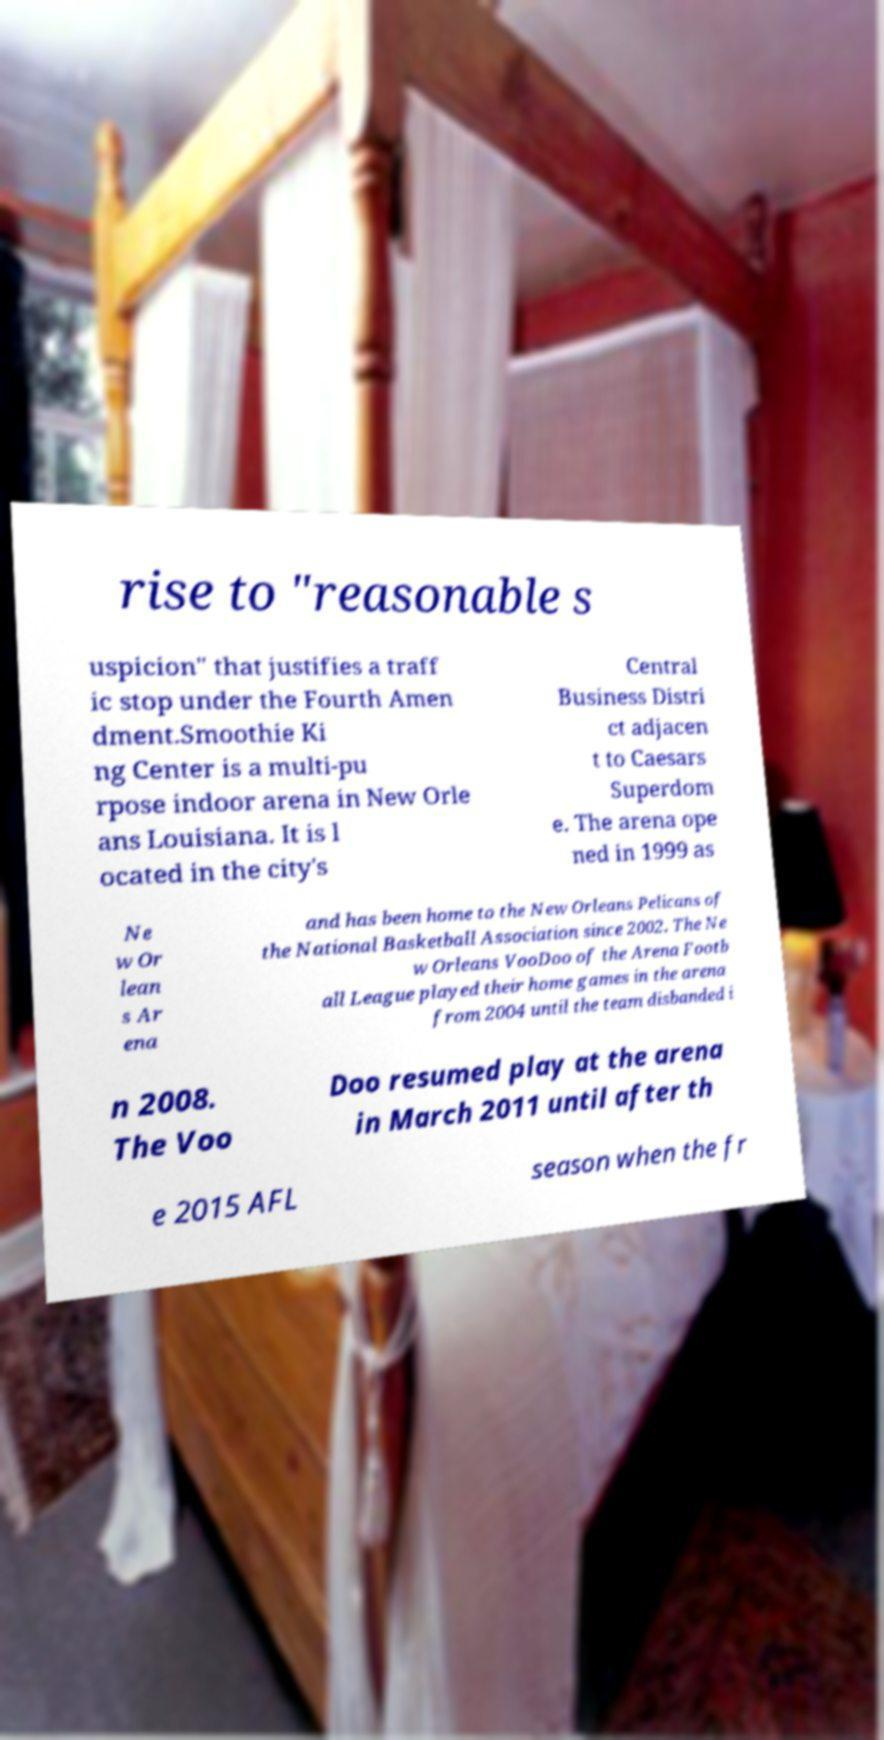I need the written content from this picture converted into text. Can you do that? rise to "reasonable s uspicion" that justifies a traff ic stop under the Fourth Amen dment.Smoothie Ki ng Center is a multi-pu rpose indoor arena in New Orle ans Louisiana. It is l ocated in the city's Central Business Distri ct adjacen t to Caesars Superdom e. The arena ope ned in 1999 as Ne w Or lean s Ar ena and has been home to the New Orleans Pelicans of the National Basketball Association since 2002. The Ne w Orleans VooDoo of the Arena Footb all League played their home games in the arena from 2004 until the team disbanded i n 2008. The Voo Doo resumed play at the arena in March 2011 until after th e 2015 AFL season when the fr 